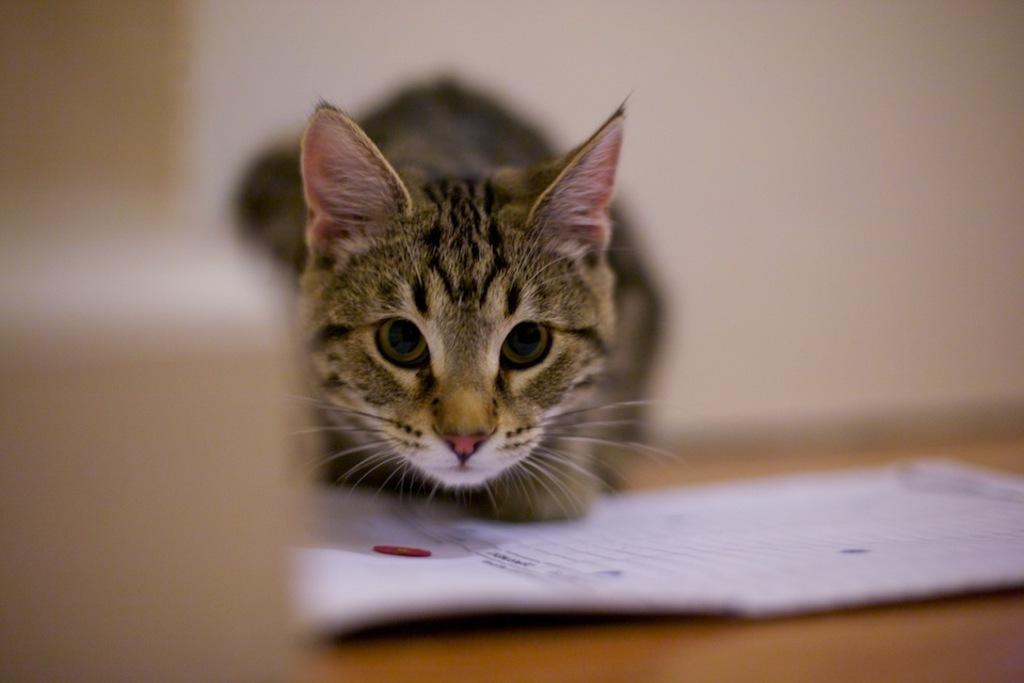Describe this image in one or two sentences. In this picture we can see a cat and in front of the cat there is a paper. Behind the cat there is the blurred background. 